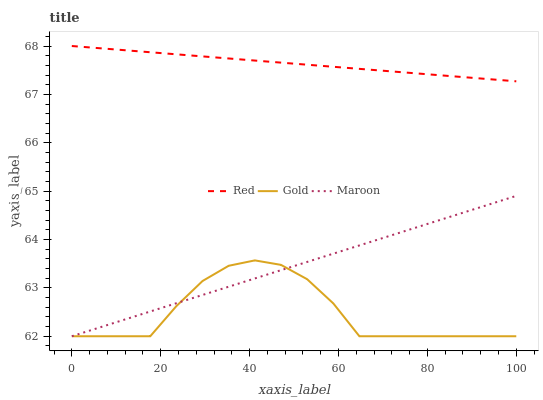Does Gold have the minimum area under the curve?
Answer yes or no. Yes. Does Red have the maximum area under the curve?
Answer yes or no. Yes. Does Red have the minimum area under the curve?
Answer yes or no. No. Does Gold have the maximum area under the curve?
Answer yes or no. No. Is Maroon the smoothest?
Answer yes or no. Yes. Is Gold the roughest?
Answer yes or no. Yes. Is Red the smoothest?
Answer yes or no. No. Is Red the roughest?
Answer yes or no. No. Does Maroon have the lowest value?
Answer yes or no. Yes. Does Red have the lowest value?
Answer yes or no. No. Does Red have the highest value?
Answer yes or no. Yes. Does Gold have the highest value?
Answer yes or no. No. Is Maroon less than Red?
Answer yes or no. Yes. Is Red greater than Maroon?
Answer yes or no. Yes. Does Maroon intersect Gold?
Answer yes or no. Yes. Is Maroon less than Gold?
Answer yes or no. No. Is Maroon greater than Gold?
Answer yes or no. No. Does Maroon intersect Red?
Answer yes or no. No. 